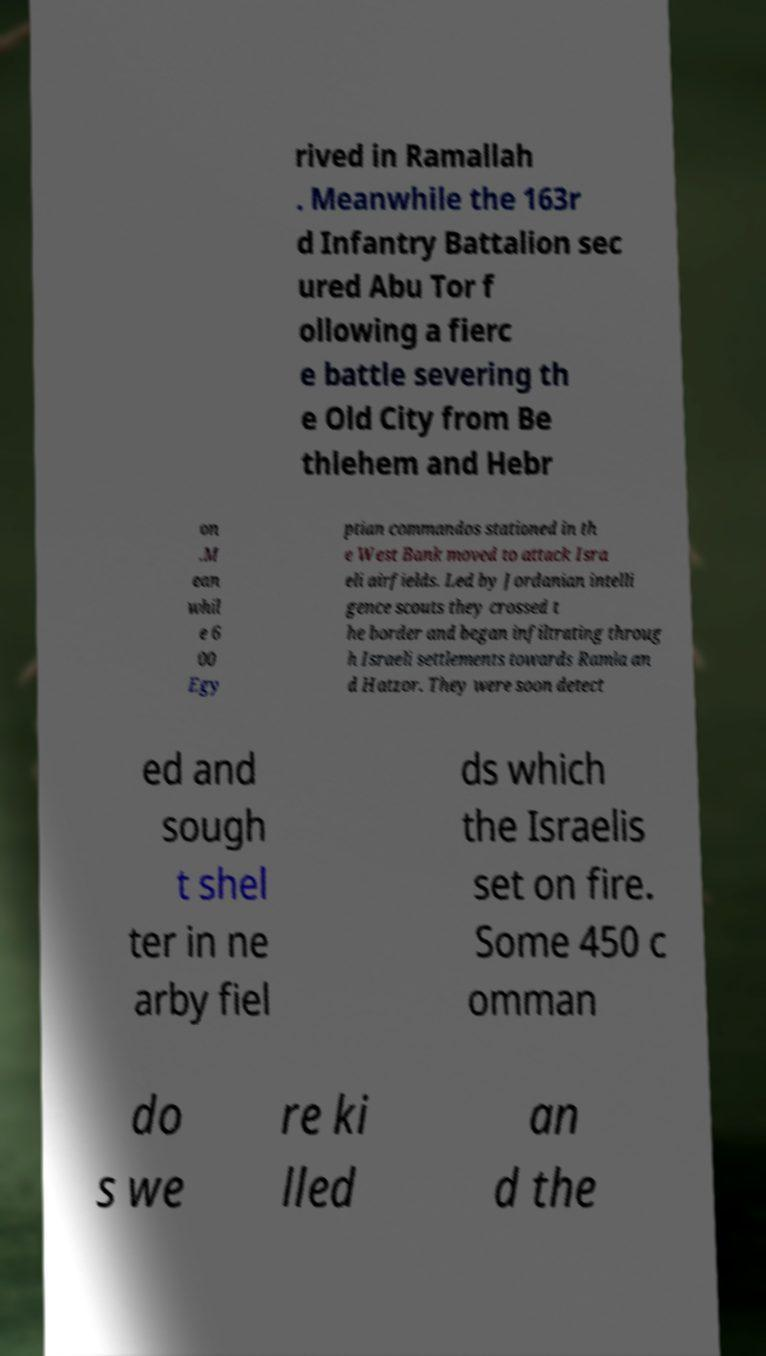There's text embedded in this image that I need extracted. Can you transcribe it verbatim? rived in Ramallah . Meanwhile the 163r d Infantry Battalion sec ured Abu Tor f ollowing a fierc e battle severing th e Old City from Be thlehem and Hebr on .M ean whil e 6 00 Egy ptian commandos stationed in th e West Bank moved to attack Isra eli airfields. Led by Jordanian intelli gence scouts they crossed t he border and began infiltrating throug h Israeli settlements towards Ramla an d Hatzor. They were soon detect ed and sough t shel ter in ne arby fiel ds which the Israelis set on fire. Some 450 c omman do s we re ki lled an d the 